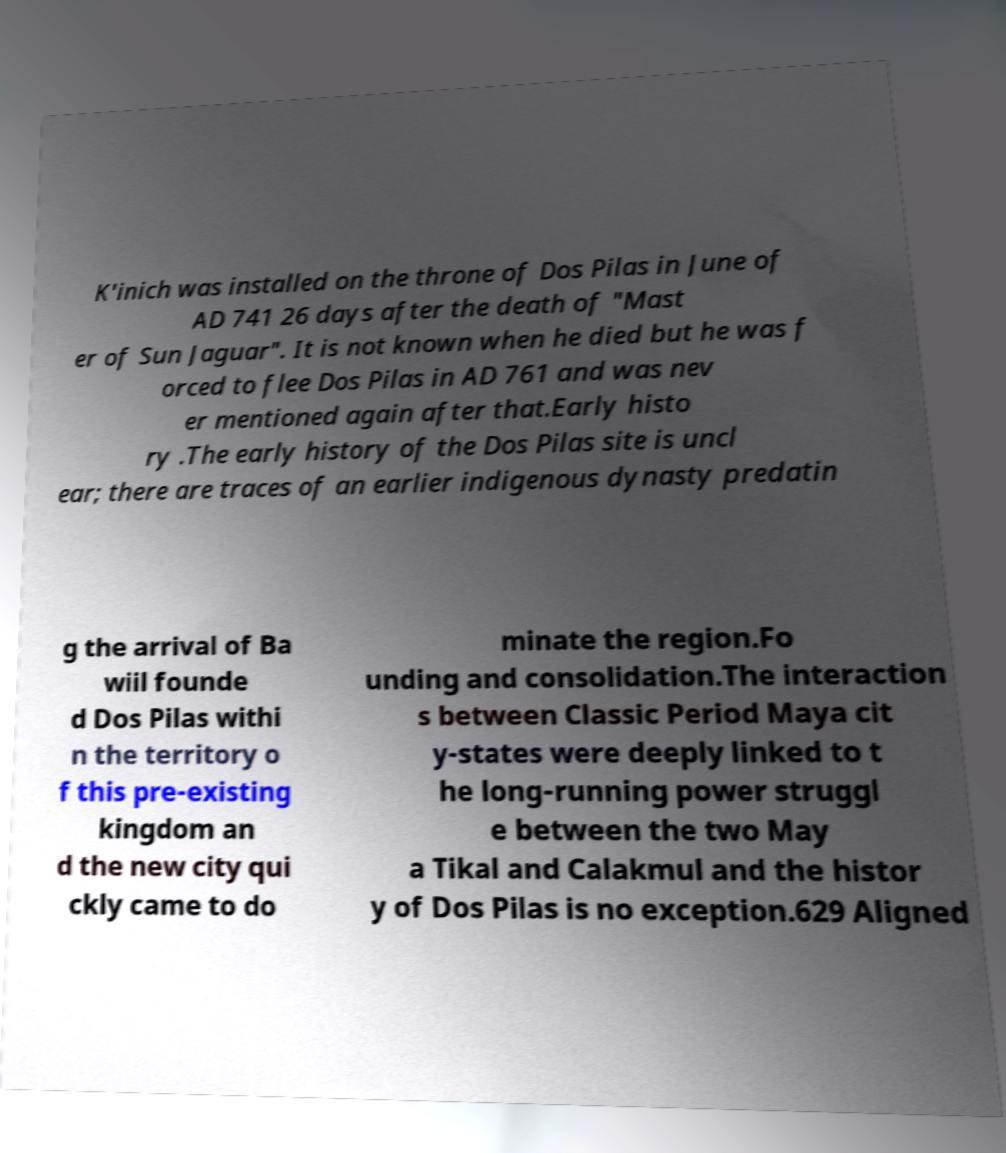What messages or text are displayed in this image? I need them in a readable, typed format. K'inich was installed on the throne of Dos Pilas in June of AD 741 26 days after the death of "Mast er of Sun Jaguar". It is not known when he died but he was f orced to flee Dos Pilas in AD 761 and was nev er mentioned again after that.Early histo ry .The early history of the Dos Pilas site is uncl ear; there are traces of an earlier indigenous dynasty predatin g the arrival of Ba wiil founde d Dos Pilas withi n the territory o f this pre-existing kingdom an d the new city qui ckly came to do minate the region.Fo unding and consolidation.The interaction s between Classic Period Maya cit y-states were deeply linked to t he long-running power struggl e between the two May a Tikal and Calakmul and the histor y of Dos Pilas is no exception.629 Aligned 